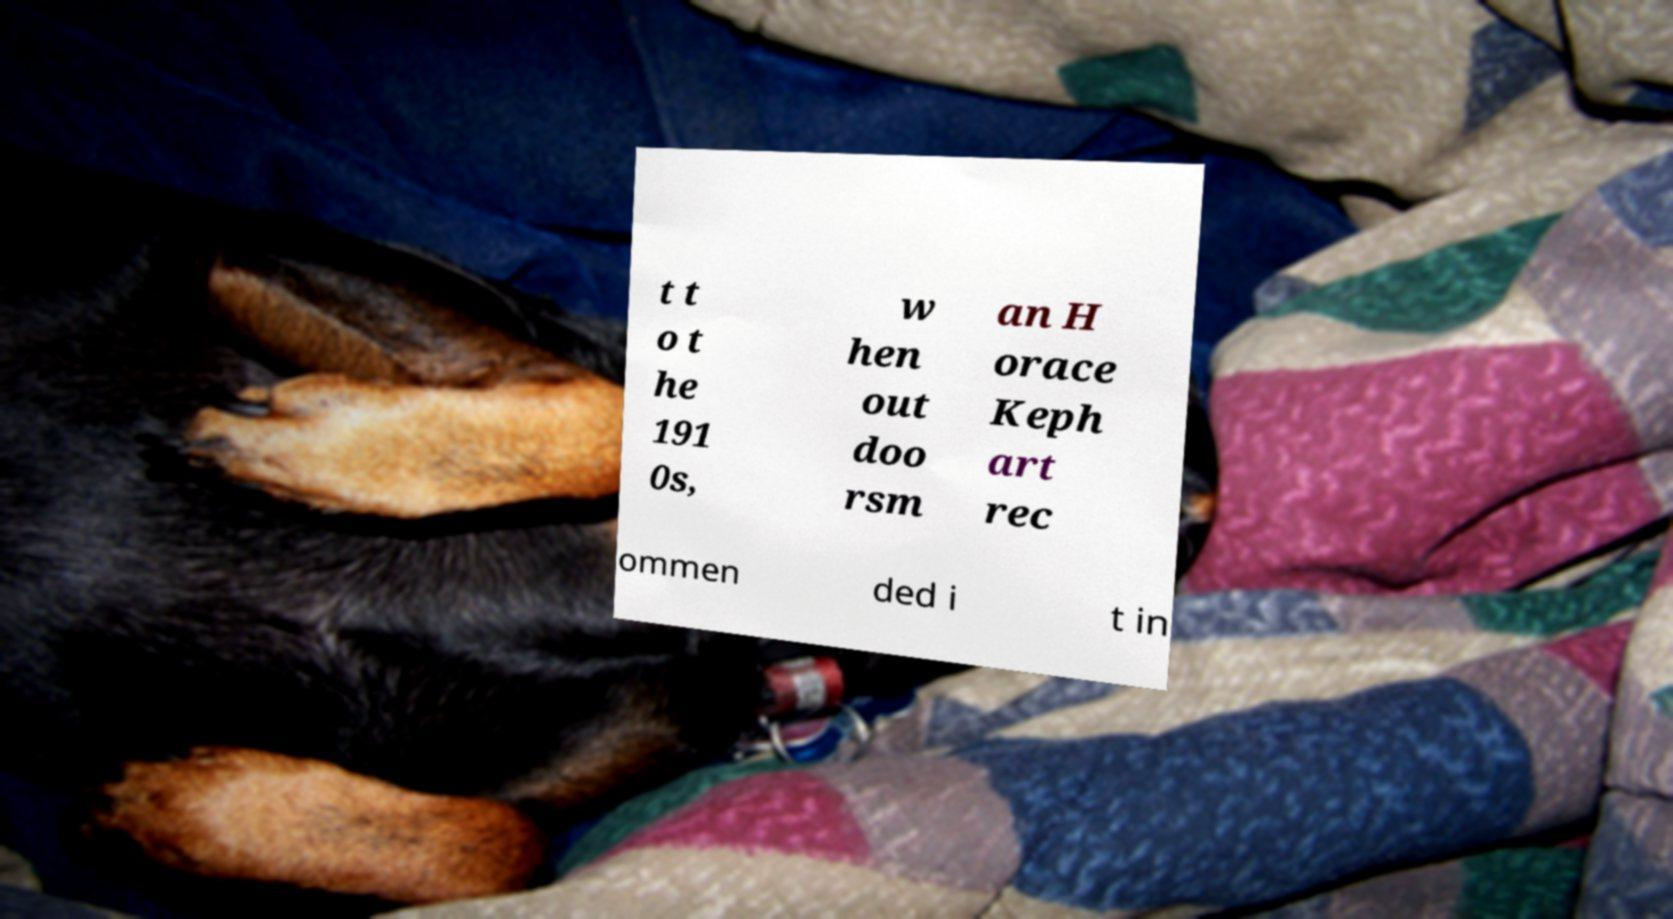Please identify and transcribe the text found in this image. t t o t he 191 0s, w hen out doo rsm an H orace Keph art rec ommen ded i t in 